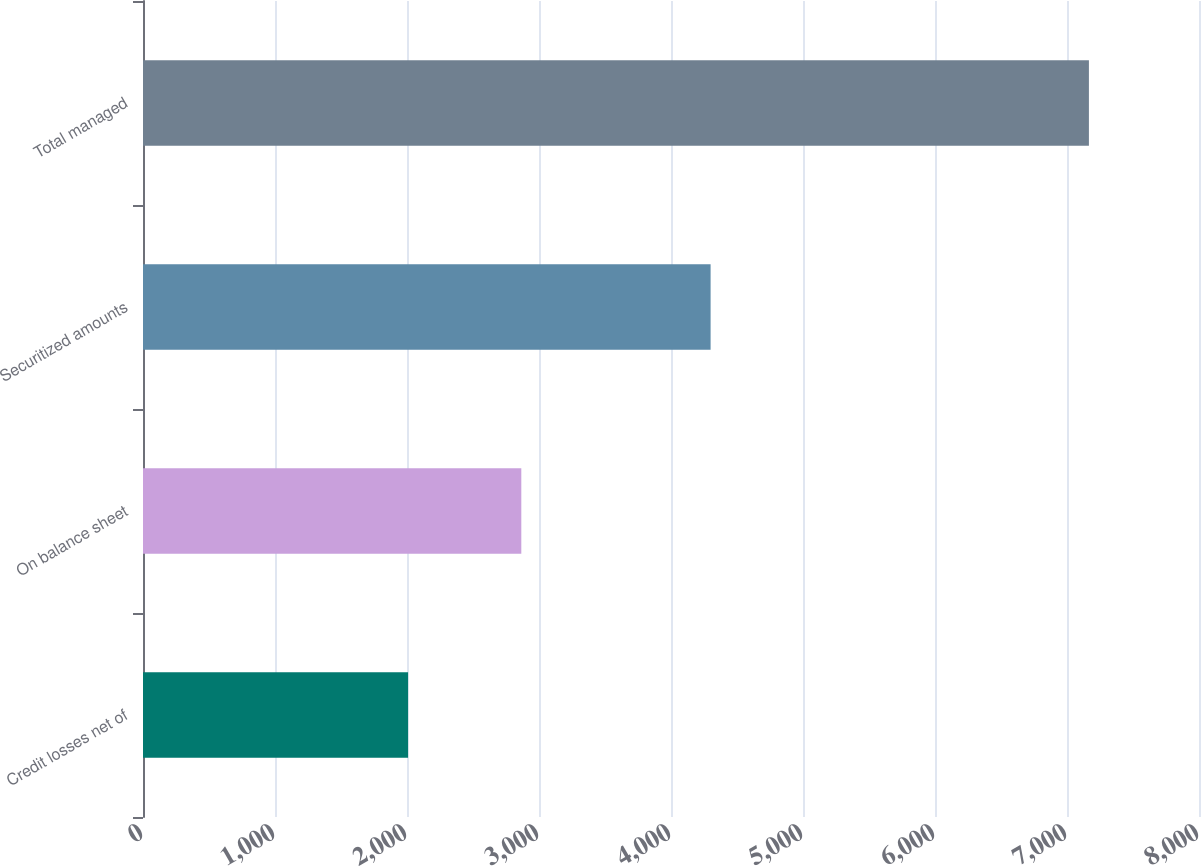<chart> <loc_0><loc_0><loc_500><loc_500><bar_chart><fcel>Credit losses net of<fcel>On balance sheet<fcel>Securitized amounts<fcel>Total managed<nl><fcel>2008<fcel>2866<fcel>4300<fcel>7166<nl></chart> 